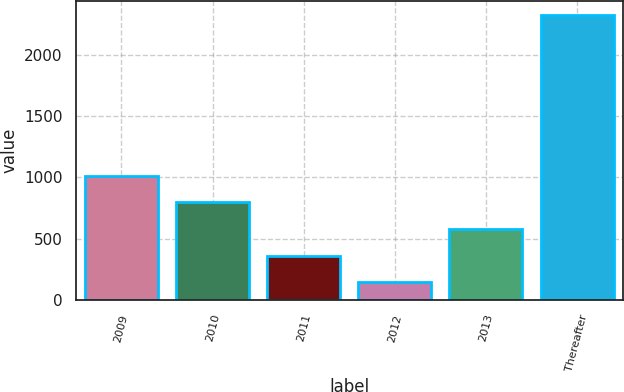<chart> <loc_0><loc_0><loc_500><loc_500><bar_chart><fcel>2009<fcel>2010<fcel>2011<fcel>2012<fcel>2013<fcel>Thereafter<nl><fcel>1015.44<fcel>797.68<fcel>362.16<fcel>144.4<fcel>579.92<fcel>2322<nl></chart> 